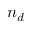<formula> <loc_0><loc_0><loc_500><loc_500>n _ { d }</formula> 